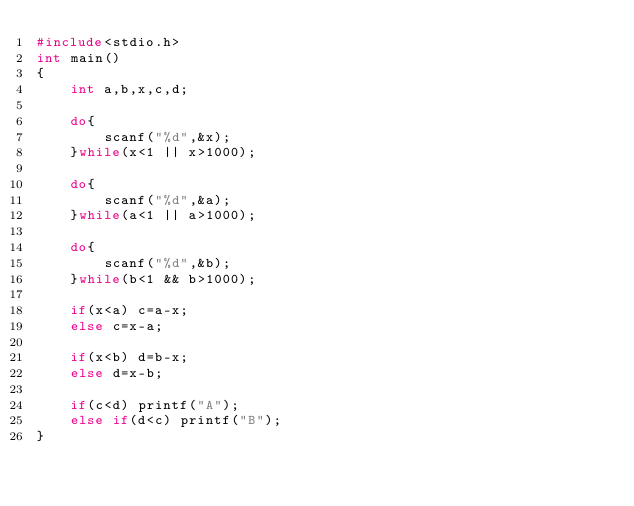<code> <loc_0><loc_0><loc_500><loc_500><_C_>#include<stdio.h>
int main()
{
    int a,b,x,c,d;

    do{
        scanf("%d",&x);
    }while(x<1 || x>1000);

    do{
        scanf("%d",&a);
    }while(a<1 || a>1000);

    do{
        scanf("%d",&b);
    }while(b<1 && b>1000);

    if(x<a) c=a-x;
    else c=x-a;

    if(x<b) d=b-x;
    else d=x-b;

    if(c<d) printf("A");
    else if(d<c) printf("B");
}
</code> 